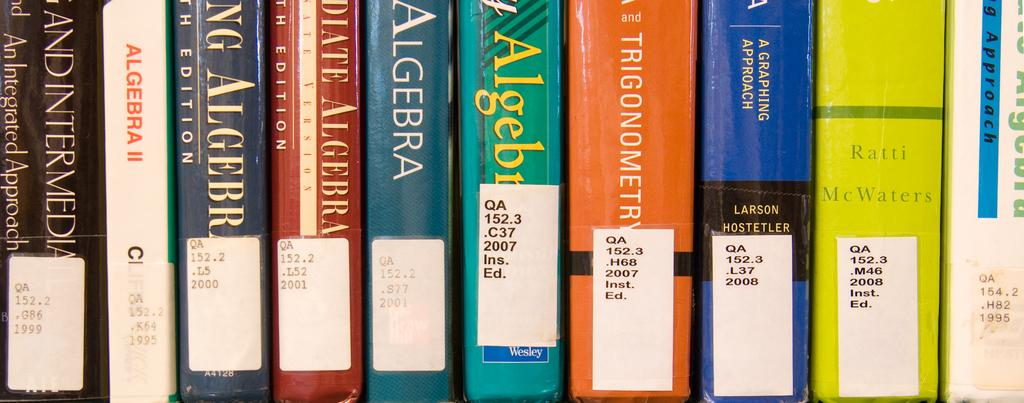<image>
Create a compact narrative representing the image presented. A row of different colored algebra and trigonometry books all with library stickers on the spine. 